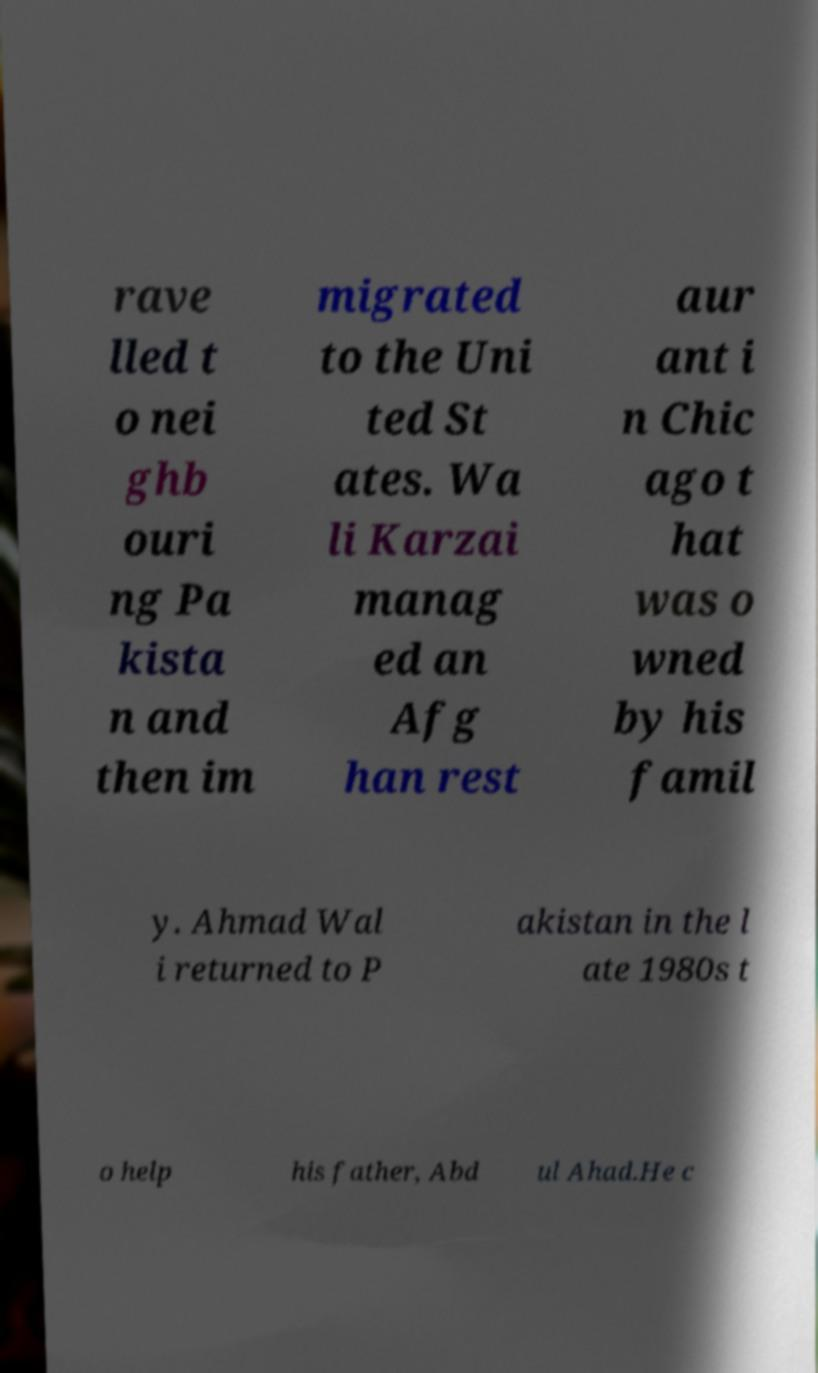Can you read and provide the text displayed in the image?This photo seems to have some interesting text. Can you extract and type it out for me? rave lled t o nei ghb ouri ng Pa kista n and then im migrated to the Uni ted St ates. Wa li Karzai manag ed an Afg han rest aur ant i n Chic ago t hat was o wned by his famil y. Ahmad Wal i returned to P akistan in the l ate 1980s t o help his father, Abd ul Ahad.He c 